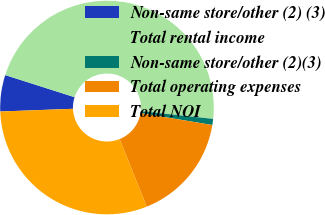Convert chart. <chart><loc_0><loc_0><loc_500><loc_500><pie_chart><fcel>Non-same store/other (2) (3)<fcel>Total rental income<fcel>Non-same store/other (2)(3)<fcel>Total operating expenses<fcel>Total NOI<nl><fcel>5.51%<fcel>46.79%<fcel>0.92%<fcel>16.31%<fcel>30.48%<nl></chart> 